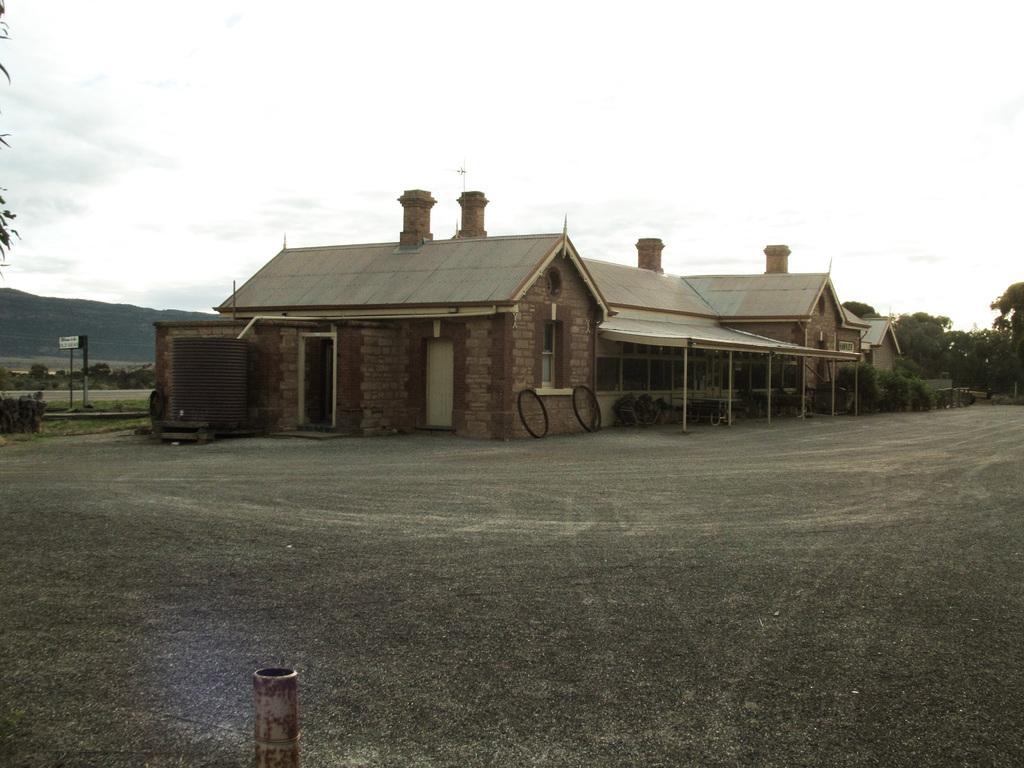Could you give a brief overview of what you see in this image? This image is taken outdoors. At the top of the image there is the sky with clouds. At the bottom of the image there is a ground with grass on it. There is an iron bar. In the background there is a hill. There are a few plants and trees on the ground. On the left side of the image there is a tree. There is a board with a text on it and there is a pole. In the middle of the image there are a few houses with walls, windows, doors and roofs. There are a few plants on the ground. 